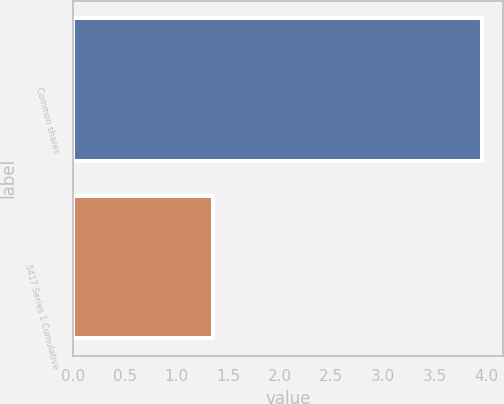Convert chart to OTSL. <chart><loc_0><loc_0><loc_500><loc_500><bar_chart><fcel>Common shares<fcel>5417 Series 1 Cumulative<nl><fcel>3.96<fcel>1.35<nl></chart> 